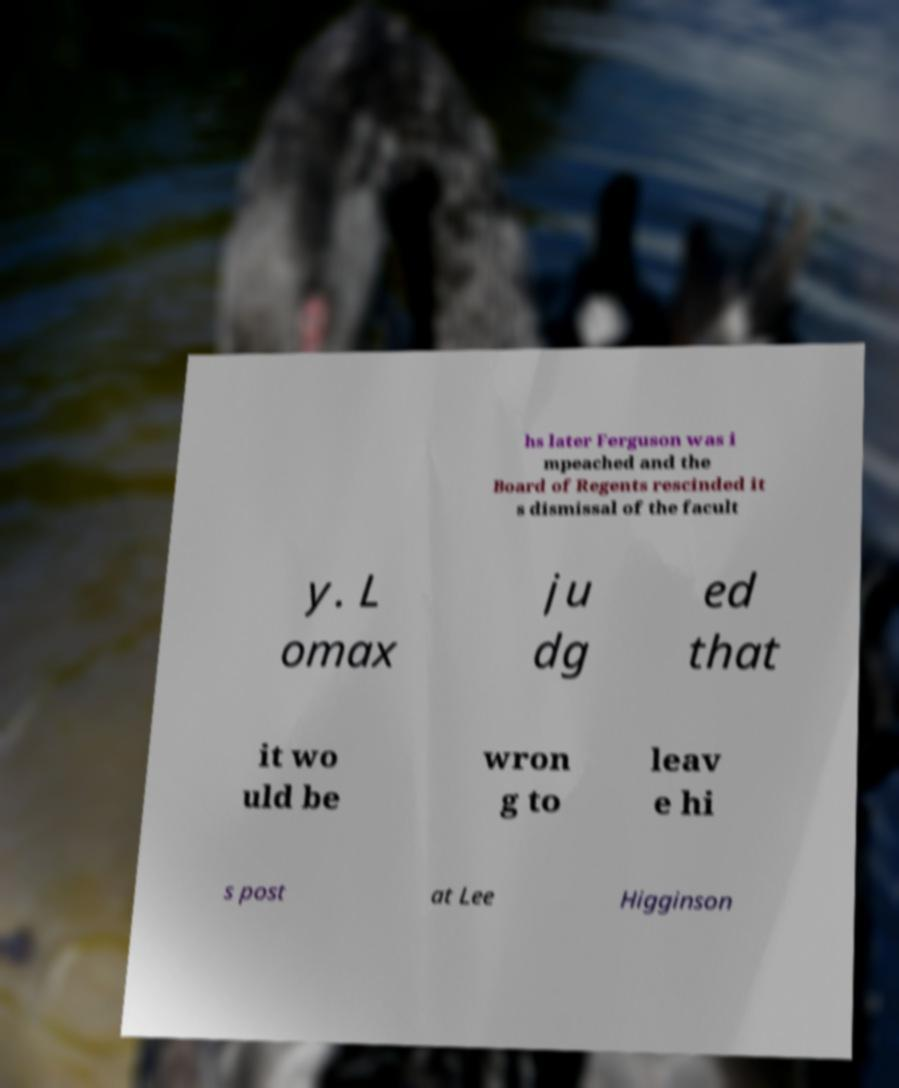Please identify and transcribe the text found in this image. hs later Ferguson was i mpeached and the Board of Regents rescinded it s dismissal of the facult y. L omax ju dg ed that it wo uld be wron g to leav e hi s post at Lee Higginson 